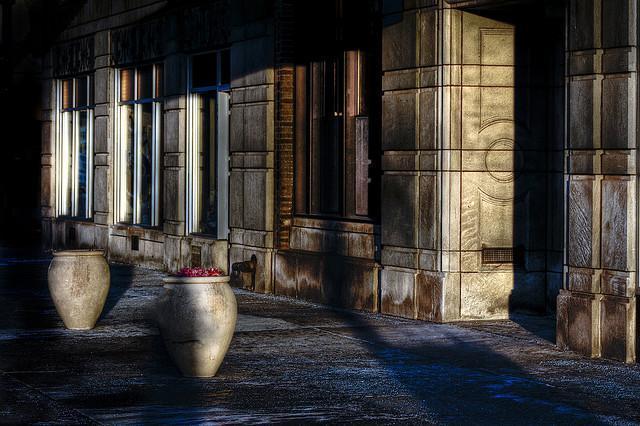How many of the birds are sitting?
Give a very brief answer. 0. 